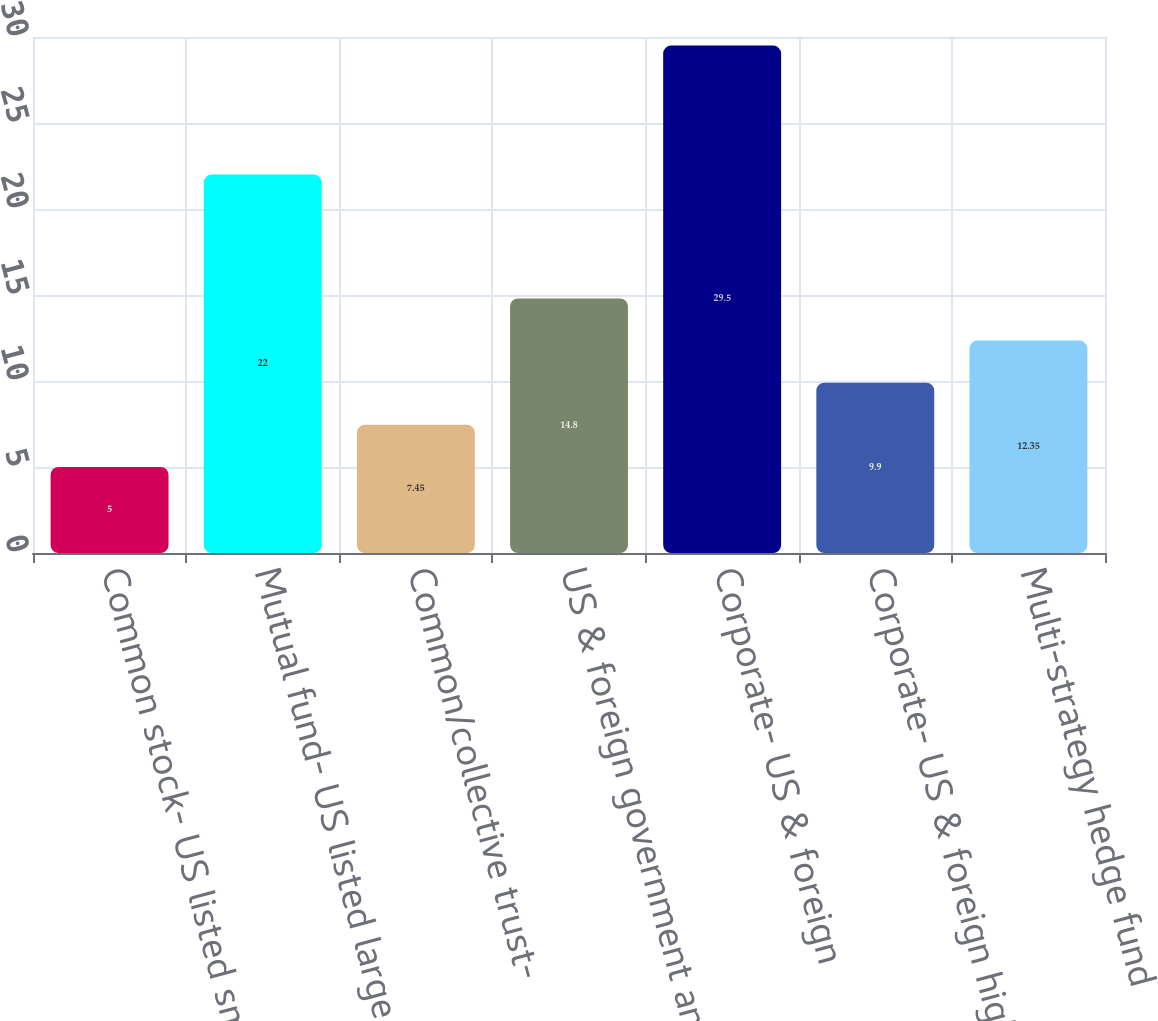<chart> <loc_0><loc_0><loc_500><loc_500><bar_chart><fcel>Common stock- US listed small<fcel>Mutual fund- US listed large<fcel>Common/collective trust-<fcel>US & foreign government and<fcel>Corporate- US & foreign<fcel>Corporate- US & foreign high<fcel>Multi-strategy hedge fund<nl><fcel>5<fcel>22<fcel>7.45<fcel>14.8<fcel>29.5<fcel>9.9<fcel>12.35<nl></chart> 